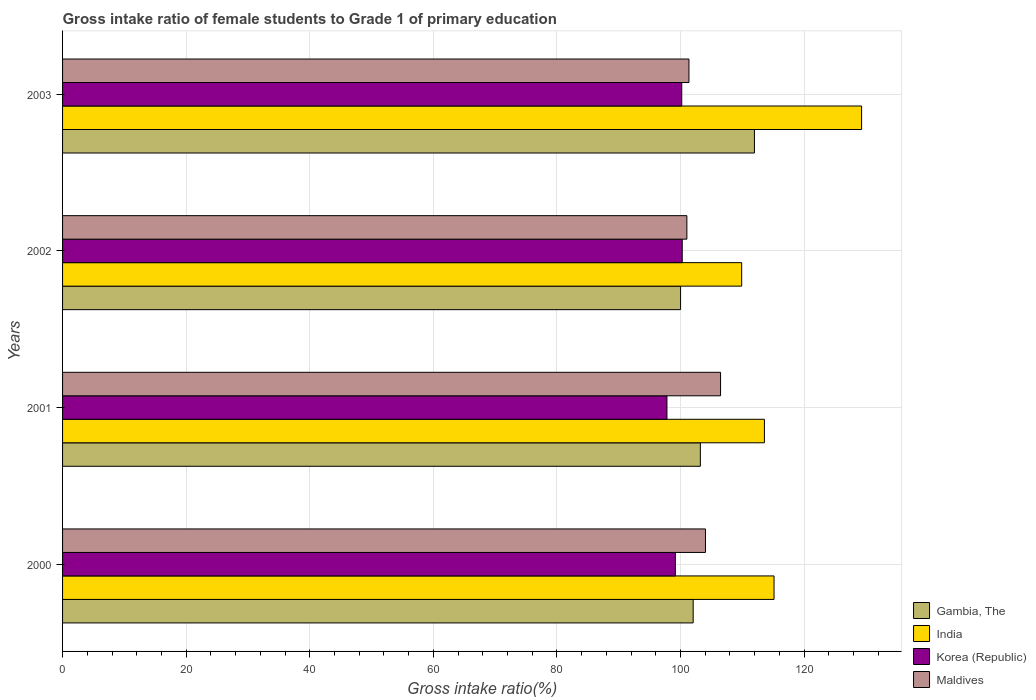Are the number of bars per tick equal to the number of legend labels?
Give a very brief answer. Yes. Are the number of bars on each tick of the Y-axis equal?
Make the answer very short. Yes. How many bars are there on the 2nd tick from the top?
Make the answer very short. 4. In how many cases, is the number of bars for a given year not equal to the number of legend labels?
Make the answer very short. 0. What is the gross intake ratio in Korea (Republic) in 2001?
Offer a very short reply. 97.8. Across all years, what is the maximum gross intake ratio in India?
Give a very brief answer. 129.3. Across all years, what is the minimum gross intake ratio in Maldives?
Provide a succinct answer. 101.03. In which year was the gross intake ratio in Korea (Republic) maximum?
Give a very brief answer. 2002. In which year was the gross intake ratio in Maldives minimum?
Your answer should be very brief. 2002. What is the total gross intake ratio in Korea (Republic) in the graph?
Your answer should be compact. 397.45. What is the difference between the gross intake ratio in Korea (Republic) in 2000 and that in 2002?
Keep it short and to the point. -1.11. What is the difference between the gross intake ratio in India in 2003 and the gross intake ratio in Gambia, The in 2002?
Provide a succinct answer. 29.29. What is the average gross intake ratio in Korea (Republic) per year?
Your answer should be compact. 99.36. In the year 2001, what is the difference between the gross intake ratio in Korea (Republic) and gross intake ratio in India?
Your response must be concise. -15.77. What is the ratio of the gross intake ratio in Maldives in 2000 to that in 2002?
Keep it short and to the point. 1.03. Is the gross intake ratio in Korea (Republic) in 2002 less than that in 2003?
Provide a succinct answer. No. Is the difference between the gross intake ratio in Korea (Republic) in 2002 and 2003 greater than the difference between the gross intake ratio in India in 2002 and 2003?
Keep it short and to the point. Yes. What is the difference between the highest and the second highest gross intake ratio in Maldives?
Your answer should be compact. 2.44. What is the difference between the highest and the lowest gross intake ratio in India?
Your answer should be very brief. 19.4. In how many years, is the gross intake ratio in Gambia, The greater than the average gross intake ratio in Gambia, The taken over all years?
Ensure brevity in your answer.  1. Is it the case that in every year, the sum of the gross intake ratio in Gambia, The and gross intake ratio in Maldives is greater than the sum of gross intake ratio in India and gross intake ratio in Korea (Republic)?
Provide a succinct answer. No. Are all the bars in the graph horizontal?
Keep it short and to the point. Yes. What is the difference between two consecutive major ticks on the X-axis?
Offer a terse response. 20. Are the values on the major ticks of X-axis written in scientific E-notation?
Your answer should be compact. No. Where does the legend appear in the graph?
Provide a succinct answer. Bottom right. What is the title of the graph?
Provide a short and direct response. Gross intake ratio of female students to Grade 1 of primary education. What is the label or title of the X-axis?
Make the answer very short. Gross intake ratio(%). What is the label or title of the Y-axis?
Provide a succinct answer. Years. What is the Gross intake ratio(%) in Gambia, The in 2000?
Provide a short and direct response. 102.05. What is the Gross intake ratio(%) of India in 2000?
Offer a very short reply. 115.13. What is the Gross intake ratio(%) in Korea (Republic) in 2000?
Make the answer very short. 99.16. What is the Gross intake ratio(%) in Maldives in 2000?
Keep it short and to the point. 104.04. What is the Gross intake ratio(%) in Gambia, The in 2001?
Give a very brief answer. 103.21. What is the Gross intake ratio(%) in India in 2001?
Offer a terse response. 113.58. What is the Gross intake ratio(%) of Korea (Republic) in 2001?
Ensure brevity in your answer.  97.8. What is the Gross intake ratio(%) of Maldives in 2001?
Offer a very short reply. 106.48. What is the Gross intake ratio(%) of Gambia, The in 2002?
Provide a succinct answer. 100.01. What is the Gross intake ratio(%) in India in 2002?
Ensure brevity in your answer.  109.9. What is the Gross intake ratio(%) of Korea (Republic) in 2002?
Keep it short and to the point. 100.28. What is the Gross intake ratio(%) in Maldives in 2002?
Your answer should be very brief. 101.03. What is the Gross intake ratio(%) of Gambia, The in 2003?
Your answer should be very brief. 111.96. What is the Gross intake ratio(%) in India in 2003?
Keep it short and to the point. 129.3. What is the Gross intake ratio(%) in Korea (Republic) in 2003?
Provide a short and direct response. 100.2. What is the Gross intake ratio(%) of Maldives in 2003?
Your answer should be compact. 101.36. Across all years, what is the maximum Gross intake ratio(%) in Gambia, The?
Your answer should be very brief. 111.96. Across all years, what is the maximum Gross intake ratio(%) of India?
Your answer should be compact. 129.3. Across all years, what is the maximum Gross intake ratio(%) of Korea (Republic)?
Provide a succinct answer. 100.28. Across all years, what is the maximum Gross intake ratio(%) in Maldives?
Your response must be concise. 106.48. Across all years, what is the minimum Gross intake ratio(%) of Gambia, The?
Keep it short and to the point. 100.01. Across all years, what is the minimum Gross intake ratio(%) in India?
Give a very brief answer. 109.9. Across all years, what is the minimum Gross intake ratio(%) of Korea (Republic)?
Ensure brevity in your answer.  97.8. Across all years, what is the minimum Gross intake ratio(%) of Maldives?
Provide a short and direct response. 101.03. What is the total Gross intake ratio(%) in Gambia, The in the graph?
Your answer should be very brief. 417.23. What is the total Gross intake ratio(%) of India in the graph?
Your answer should be very brief. 467.91. What is the total Gross intake ratio(%) in Korea (Republic) in the graph?
Offer a terse response. 397.45. What is the total Gross intake ratio(%) of Maldives in the graph?
Your answer should be compact. 412.91. What is the difference between the Gross intake ratio(%) of Gambia, The in 2000 and that in 2001?
Your answer should be very brief. -1.16. What is the difference between the Gross intake ratio(%) in India in 2000 and that in 2001?
Keep it short and to the point. 1.55. What is the difference between the Gross intake ratio(%) of Korea (Republic) in 2000 and that in 2001?
Your answer should be very brief. 1.36. What is the difference between the Gross intake ratio(%) of Maldives in 2000 and that in 2001?
Make the answer very short. -2.44. What is the difference between the Gross intake ratio(%) of Gambia, The in 2000 and that in 2002?
Your answer should be very brief. 2.04. What is the difference between the Gross intake ratio(%) in India in 2000 and that in 2002?
Provide a succinct answer. 5.23. What is the difference between the Gross intake ratio(%) in Korea (Republic) in 2000 and that in 2002?
Provide a short and direct response. -1.11. What is the difference between the Gross intake ratio(%) of Maldives in 2000 and that in 2002?
Your answer should be very brief. 3.01. What is the difference between the Gross intake ratio(%) in Gambia, The in 2000 and that in 2003?
Offer a very short reply. -9.91. What is the difference between the Gross intake ratio(%) in India in 2000 and that in 2003?
Provide a short and direct response. -14.17. What is the difference between the Gross intake ratio(%) of Korea (Republic) in 2000 and that in 2003?
Ensure brevity in your answer.  -1.03. What is the difference between the Gross intake ratio(%) in Maldives in 2000 and that in 2003?
Your answer should be compact. 2.67. What is the difference between the Gross intake ratio(%) in Gambia, The in 2001 and that in 2002?
Provide a succinct answer. 3.2. What is the difference between the Gross intake ratio(%) of India in 2001 and that in 2002?
Make the answer very short. 3.68. What is the difference between the Gross intake ratio(%) in Korea (Republic) in 2001 and that in 2002?
Give a very brief answer. -2.47. What is the difference between the Gross intake ratio(%) in Maldives in 2001 and that in 2002?
Provide a short and direct response. 5.45. What is the difference between the Gross intake ratio(%) of Gambia, The in 2001 and that in 2003?
Your response must be concise. -8.75. What is the difference between the Gross intake ratio(%) of India in 2001 and that in 2003?
Make the answer very short. -15.72. What is the difference between the Gross intake ratio(%) of Korea (Republic) in 2001 and that in 2003?
Your answer should be very brief. -2.4. What is the difference between the Gross intake ratio(%) in Maldives in 2001 and that in 2003?
Your answer should be very brief. 5.12. What is the difference between the Gross intake ratio(%) of Gambia, The in 2002 and that in 2003?
Keep it short and to the point. -11.95. What is the difference between the Gross intake ratio(%) of India in 2002 and that in 2003?
Ensure brevity in your answer.  -19.4. What is the difference between the Gross intake ratio(%) of Korea (Republic) in 2002 and that in 2003?
Give a very brief answer. 0.08. What is the difference between the Gross intake ratio(%) in Maldives in 2002 and that in 2003?
Give a very brief answer. -0.34. What is the difference between the Gross intake ratio(%) of Gambia, The in 2000 and the Gross intake ratio(%) of India in 2001?
Offer a very short reply. -11.53. What is the difference between the Gross intake ratio(%) of Gambia, The in 2000 and the Gross intake ratio(%) of Korea (Republic) in 2001?
Offer a terse response. 4.24. What is the difference between the Gross intake ratio(%) of Gambia, The in 2000 and the Gross intake ratio(%) of Maldives in 2001?
Give a very brief answer. -4.43. What is the difference between the Gross intake ratio(%) of India in 2000 and the Gross intake ratio(%) of Korea (Republic) in 2001?
Give a very brief answer. 17.33. What is the difference between the Gross intake ratio(%) of India in 2000 and the Gross intake ratio(%) of Maldives in 2001?
Provide a short and direct response. 8.65. What is the difference between the Gross intake ratio(%) in Korea (Republic) in 2000 and the Gross intake ratio(%) in Maldives in 2001?
Offer a terse response. -7.32. What is the difference between the Gross intake ratio(%) in Gambia, The in 2000 and the Gross intake ratio(%) in India in 2002?
Your answer should be very brief. -7.85. What is the difference between the Gross intake ratio(%) in Gambia, The in 2000 and the Gross intake ratio(%) in Korea (Republic) in 2002?
Give a very brief answer. 1.77. What is the difference between the Gross intake ratio(%) of Gambia, The in 2000 and the Gross intake ratio(%) of Maldives in 2002?
Your answer should be very brief. 1.02. What is the difference between the Gross intake ratio(%) of India in 2000 and the Gross intake ratio(%) of Korea (Republic) in 2002?
Your answer should be very brief. 14.86. What is the difference between the Gross intake ratio(%) in India in 2000 and the Gross intake ratio(%) in Maldives in 2002?
Offer a terse response. 14.11. What is the difference between the Gross intake ratio(%) in Korea (Republic) in 2000 and the Gross intake ratio(%) in Maldives in 2002?
Your response must be concise. -1.86. What is the difference between the Gross intake ratio(%) in Gambia, The in 2000 and the Gross intake ratio(%) in India in 2003?
Your response must be concise. -27.26. What is the difference between the Gross intake ratio(%) in Gambia, The in 2000 and the Gross intake ratio(%) in Korea (Republic) in 2003?
Offer a very short reply. 1.85. What is the difference between the Gross intake ratio(%) of Gambia, The in 2000 and the Gross intake ratio(%) of Maldives in 2003?
Keep it short and to the point. 0.68. What is the difference between the Gross intake ratio(%) in India in 2000 and the Gross intake ratio(%) in Korea (Republic) in 2003?
Your answer should be compact. 14.93. What is the difference between the Gross intake ratio(%) in India in 2000 and the Gross intake ratio(%) in Maldives in 2003?
Your response must be concise. 13.77. What is the difference between the Gross intake ratio(%) of Korea (Republic) in 2000 and the Gross intake ratio(%) of Maldives in 2003?
Keep it short and to the point. -2.2. What is the difference between the Gross intake ratio(%) in Gambia, The in 2001 and the Gross intake ratio(%) in India in 2002?
Ensure brevity in your answer.  -6.69. What is the difference between the Gross intake ratio(%) in Gambia, The in 2001 and the Gross intake ratio(%) in Korea (Republic) in 2002?
Your response must be concise. 2.93. What is the difference between the Gross intake ratio(%) in Gambia, The in 2001 and the Gross intake ratio(%) in Maldives in 2002?
Make the answer very short. 2.18. What is the difference between the Gross intake ratio(%) in India in 2001 and the Gross intake ratio(%) in Korea (Republic) in 2002?
Your answer should be very brief. 13.3. What is the difference between the Gross intake ratio(%) in India in 2001 and the Gross intake ratio(%) in Maldives in 2002?
Offer a very short reply. 12.55. What is the difference between the Gross intake ratio(%) in Korea (Republic) in 2001 and the Gross intake ratio(%) in Maldives in 2002?
Your response must be concise. -3.22. What is the difference between the Gross intake ratio(%) of Gambia, The in 2001 and the Gross intake ratio(%) of India in 2003?
Your answer should be very brief. -26.09. What is the difference between the Gross intake ratio(%) in Gambia, The in 2001 and the Gross intake ratio(%) in Korea (Republic) in 2003?
Provide a succinct answer. 3.01. What is the difference between the Gross intake ratio(%) in Gambia, The in 2001 and the Gross intake ratio(%) in Maldives in 2003?
Ensure brevity in your answer.  1.85. What is the difference between the Gross intake ratio(%) of India in 2001 and the Gross intake ratio(%) of Korea (Republic) in 2003?
Your response must be concise. 13.38. What is the difference between the Gross intake ratio(%) of India in 2001 and the Gross intake ratio(%) of Maldives in 2003?
Your answer should be compact. 12.21. What is the difference between the Gross intake ratio(%) in Korea (Republic) in 2001 and the Gross intake ratio(%) in Maldives in 2003?
Give a very brief answer. -3.56. What is the difference between the Gross intake ratio(%) of Gambia, The in 2002 and the Gross intake ratio(%) of India in 2003?
Offer a terse response. -29.29. What is the difference between the Gross intake ratio(%) of Gambia, The in 2002 and the Gross intake ratio(%) of Korea (Republic) in 2003?
Ensure brevity in your answer.  -0.19. What is the difference between the Gross intake ratio(%) in Gambia, The in 2002 and the Gross intake ratio(%) in Maldives in 2003?
Make the answer very short. -1.35. What is the difference between the Gross intake ratio(%) of India in 2002 and the Gross intake ratio(%) of Korea (Republic) in 2003?
Offer a very short reply. 9.7. What is the difference between the Gross intake ratio(%) in India in 2002 and the Gross intake ratio(%) in Maldives in 2003?
Your answer should be compact. 8.54. What is the difference between the Gross intake ratio(%) of Korea (Republic) in 2002 and the Gross intake ratio(%) of Maldives in 2003?
Your response must be concise. -1.09. What is the average Gross intake ratio(%) of Gambia, The per year?
Offer a very short reply. 104.31. What is the average Gross intake ratio(%) of India per year?
Ensure brevity in your answer.  116.98. What is the average Gross intake ratio(%) of Korea (Republic) per year?
Offer a terse response. 99.36. What is the average Gross intake ratio(%) of Maldives per year?
Give a very brief answer. 103.23. In the year 2000, what is the difference between the Gross intake ratio(%) of Gambia, The and Gross intake ratio(%) of India?
Give a very brief answer. -13.09. In the year 2000, what is the difference between the Gross intake ratio(%) of Gambia, The and Gross intake ratio(%) of Korea (Republic)?
Give a very brief answer. 2.88. In the year 2000, what is the difference between the Gross intake ratio(%) in Gambia, The and Gross intake ratio(%) in Maldives?
Your response must be concise. -1.99. In the year 2000, what is the difference between the Gross intake ratio(%) of India and Gross intake ratio(%) of Korea (Republic)?
Your answer should be compact. 15.97. In the year 2000, what is the difference between the Gross intake ratio(%) of India and Gross intake ratio(%) of Maldives?
Give a very brief answer. 11.1. In the year 2000, what is the difference between the Gross intake ratio(%) of Korea (Republic) and Gross intake ratio(%) of Maldives?
Offer a terse response. -4.87. In the year 2001, what is the difference between the Gross intake ratio(%) of Gambia, The and Gross intake ratio(%) of India?
Ensure brevity in your answer.  -10.37. In the year 2001, what is the difference between the Gross intake ratio(%) in Gambia, The and Gross intake ratio(%) in Korea (Republic)?
Offer a terse response. 5.41. In the year 2001, what is the difference between the Gross intake ratio(%) of Gambia, The and Gross intake ratio(%) of Maldives?
Offer a very short reply. -3.27. In the year 2001, what is the difference between the Gross intake ratio(%) in India and Gross intake ratio(%) in Korea (Republic)?
Provide a succinct answer. 15.77. In the year 2001, what is the difference between the Gross intake ratio(%) of India and Gross intake ratio(%) of Maldives?
Your answer should be very brief. 7.1. In the year 2001, what is the difference between the Gross intake ratio(%) in Korea (Republic) and Gross intake ratio(%) in Maldives?
Keep it short and to the point. -8.68. In the year 2002, what is the difference between the Gross intake ratio(%) of Gambia, The and Gross intake ratio(%) of India?
Keep it short and to the point. -9.89. In the year 2002, what is the difference between the Gross intake ratio(%) of Gambia, The and Gross intake ratio(%) of Korea (Republic)?
Provide a succinct answer. -0.27. In the year 2002, what is the difference between the Gross intake ratio(%) of Gambia, The and Gross intake ratio(%) of Maldives?
Offer a very short reply. -1.02. In the year 2002, what is the difference between the Gross intake ratio(%) of India and Gross intake ratio(%) of Korea (Republic)?
Provide a succinct answer. 9.62. In the year 2002, what is the difference between the Gross intake ratio(%) of India and Gross intake ratio(%) of Maldives?
Offer a terse response. 8.87. In the year 2002, what is the difference between the Gross intake ratio(%) in Korea (Republic) and Gross intake ratio(%) in Maldives?
Your answer should be very brief. -0.75. In the year 2003, what is the difference between the Gross intake ratio(%) of Gambia, The and Gross intake ratio(%) of India?
Your answer should be compact. -17.34. In the year 2003, what is the difference between the Gross intake ratio(%) in Gambia, The and Gross intake ratio(%) in Korea (Republic)?
Give a very brief answer. 11.76. In the year 2003, what is the difference between the Gross intake ratio(%) of Gambia, The and Gross intake ratio(%) of Maldives?
Your answer should be compact. 10.6. In the year 2003, what is the difference between the Gross intake ratio(%) of India and Gross intake ratio(%) of Korea (Republic)?
Make the answer very short. 29.1. In the year 2003, what is the difference between the Gross intake ratio(%) of India and Gross intake ratio(%) of Maldives?
Offer a terse response. 27.94. In the year 2003, what is the difference between the Gross intake ratio(%) of Korea (Republic) and Gross intake ratio(%) of Maldives?
Provide a short and direct response. -1.16. What is the ratio of the Gross intake ratio(%) of Gambia, The in 2000 to that in 2001?
Provide a short and direct response. 0.99. What is the ratio of the Gross intake ratio(%) of India in 2000 to that in 2001?
Offer a terse response. 1.01. What is the ratio of the Gross intake ratio(%) in Korea (Republic) in 2000 to that in 2001?
Your answer should be very brief. 1.01. What is the ratio of the Gross intake ratio(%) of Maldives in 2000 to that in 2001?
Ensure brevity in your answer.  0.98. What is the ratio of the Gross intake ratio(%) in Gambia, The in 2000 to that in 2002?
Keep it short and to the point. 1.02. What is the ratio of the Gross intake ratio(%) in India in 2000 to that in 2002?
Give a very brief answer. 1.05. What is the ratio of the Gross intake ratio(%) in Korea (Republic) in 2000 to that in 2002?
Provide a short and direct response. 0.99. What is the ratio of the Gross intake ratio(%) of Maldives in 2000 to that in 2002?
Give a very brief answer. 1.03. What is the ratio of the Gross intake ratio(%) in Gambia, The in 2000 to that in 2003?
Make the answer very short. 0.91. What is the ratio of the Gross intake ratio(%) in India in 2000 to that in 2003?
Offer a terse response. 0.89. What is the ratio of the Gross intake ratio(%) of Maldives in 2000 to that in 2003?
Your answer should be very brief. 1.03. What is the ratio of the Gross intake ratio(%) of Gambia, The in 2001 to that in 2002?
Provide a succinct answer. 1.03. What is the ratio of the Gross intake ratio(%) of India in 2001 to that in 2002?
Ensure brevity in your answer.  1.03. What is the ratio of the Gross intake ratio(%) of Korea (Republic) in 2001 to that in 2002?
Offer a very short reply. 0.98. What is the ratio of the Gross intake ratio(%) of Maldives in 2001 to that in 2002?
Make the answer very short. 1.05. What is the ratio of the Gross intake ratio(%) of Gambia, The in 2001 to that in 2003?
Keep it short and to the point. 0.92. What is the ratio of the Gross intake ratio(%) in India in 2001 to that in 2003?
Your response must be concise. 0.88. What is the ratio of the Gross intake ratio(%) of Korea (Republic) in 2001 to that in 2003?
Your response must be concise. 0.98. What is the ratio of the Gross intake ratio(%) of Maldives in 2001 to that in 2003?
Your answer should be compact. 1.05. What is the ratio of the Gross intake ratio(%) of Gambia, The in 2002 to that in 2003?
Offer a very short reply. 0.89. What is the ratio of the Gross intake ratio(%) in India in 2002 to that in 2003?
Ensure brevity in your answer.  0.85. What is the difference between the highest and the second highest Gross intake ratio(%) in Gambia, The?
Your answer should be very brief. 8.75. What is the difference between the highest and the second highest Gross intake ratio(%) in India?
Provide a short and direct response. 14.17. What is the difference between the highest and the second highest Gross intake ratio(%) of Korea (Republic)?
Your response must be concise. 0.08. What is the difference between the highest and the second highest Gross intake ratio(%) of Maldives?
Offer a very short reply. 2.44. What is the difference between the highest and the lowest Gross intake ratio(%) in Gambia, The?
Offer a terse response. 11.95. What is the difference between the highest and the lowest Gross intake ratio(%) in India?
Provide a short and direct response. 19.4. What is the difference between the highest and the lowest Gross intake ratio(%) in Korea (Republic)?
Provide a succinct answer. 2.47. What is the difference between the highest and the lowest Gross intake ratio(%) in Maldives?
Your answer should be compact. 5.45. 